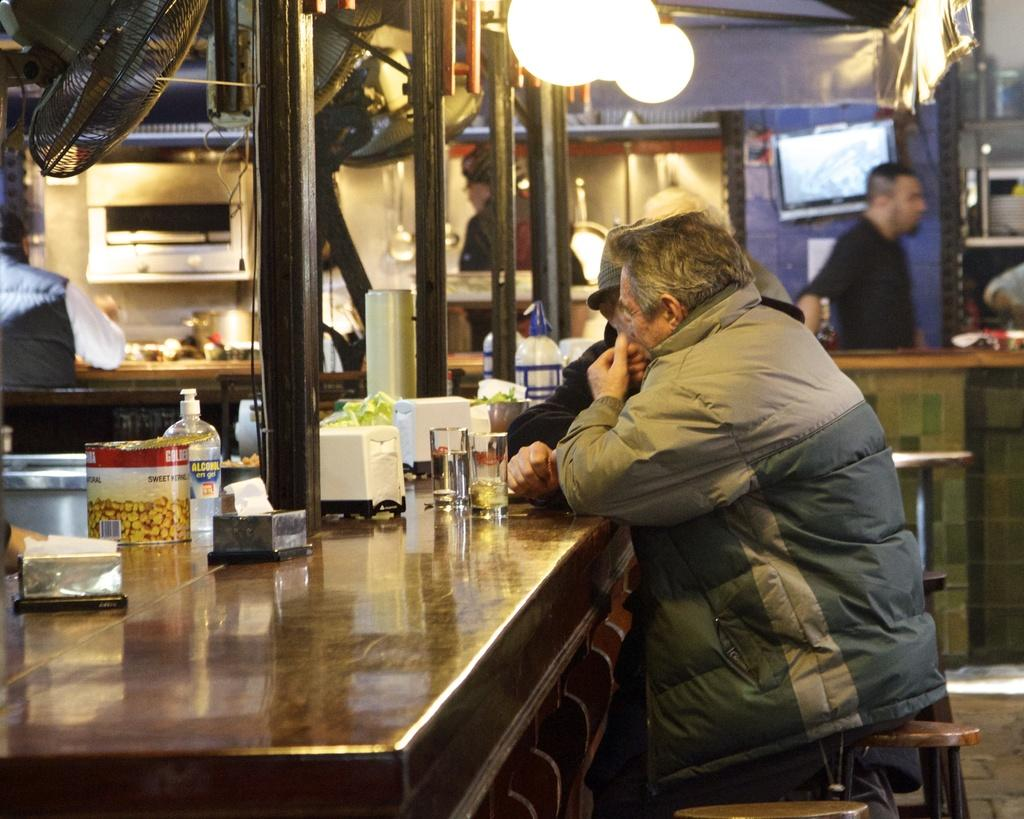What are the people in the image doing? The people are sitting at stools in the image. What direction are the people looking? The people are looking at the left side in the image. What can be seen at the top of the image? There are lights at the top in the image. Can you describe the man's position in the image? There is a man standing on the right side of the image. What type of brass instrument is the man playing in the image? There is no brass instrument or indication of music in the image; the man is simply standing on the right side. 